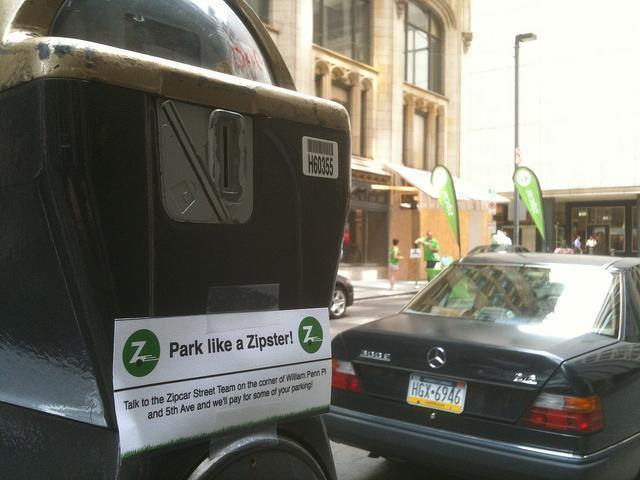What make of car can be seen next to the parking meter?
Choose the right answer and clarify with the format: 'Answer: answer
Rationale: rationale.'
Options: Mercedes, acura, audi, bmw. Answer: mercedes.
Rationale: One can see their familiar three- pronged logo on the back of the car. 